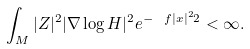<formula> <loc_0><loc_0><loc_500><loc_500>\int _ { M } | Z | ^ { 2 } | \nabla \log H | ^ { 2 } e ^ { - \ f { | x | ^ { 2 } } { 2 } } < \infty .</formula> 